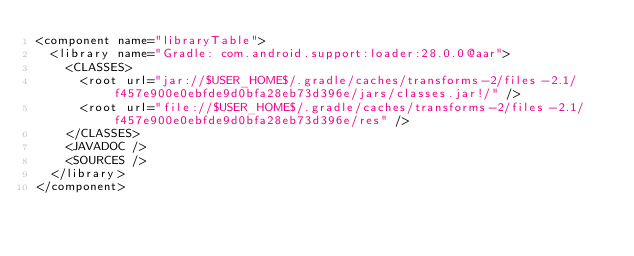<code> <loc_0><loc_0><loc_500><loc_500><_XML_><component name="libraryTable">
  <library name="Gradle: com.android.support:loader:28.0.0@aar">
    <CLASSES>
      <root url="jar://$USER_HOME$/.gradle/caches/transforms-2/files-2.1/f457e900e0ebfde9d0bfa28eb73d396e/jars/classes.jar!/" />
      <root url="file://$USER_HOME$/.gradle/caches/transforms-2/files-2.1/f457e900e0ebfde9d0bfa28eb73d396e/res" />
    </CLASSES>
    <JAVADOC />
    <SOURCES />
  </library>
</component></code> 